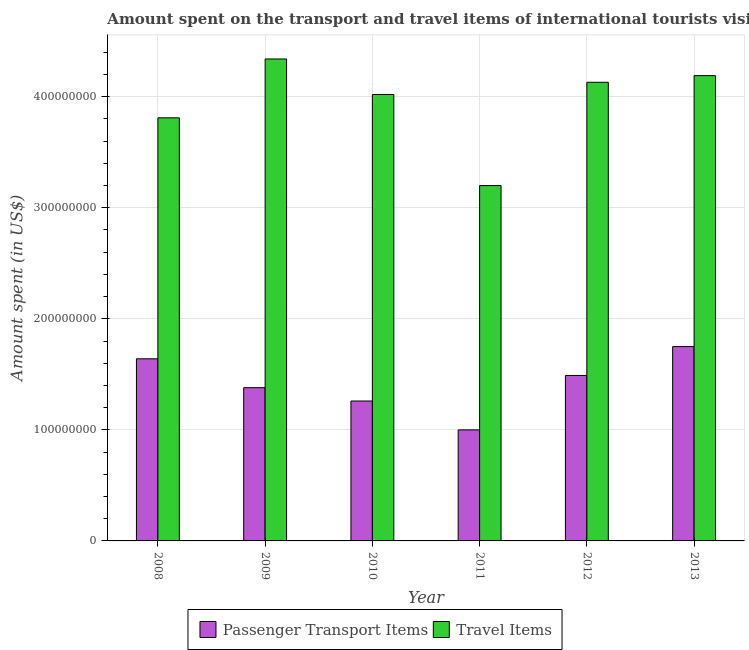How many different coloured bars are there?
Provide a succinct answer. 2. How many groups of bars are there?
Make the answer very short. 6. Are the number of bars per tick equal to the number of legend labels?
Your response must be concise. Yes. How many bars are there on the 1st tick from the left?
Ensure brevity in your answer.  2. How many bars are there on the 1st tick from the right?
Make the answer very short. 2. What is the label of the 2nd group of bars from the left?
Provide a succinct answer. 2009. What is the amount spent in travel items in 2008?
Make the answer very short. 3.81e+08. Across all years, what is the maximum amount spent in travel items?
Provide a succinct answer. 4.34e+08. Across all years, what is the minimum amount spent in travel items?
Make the answer very short. 3.20e+08. In which year was the amount spent on passenger transport items maximum?
Provide a short and direct response. 2013. What is the total amount spent on passenger transport items in the graph?
Ensure brevity in your answer.  8.52e+08. What is the difference between the amount spent in travel items in 2008 and that in 2009?
Offer a very short reply. -5.30e+07. What is the difference between the amount spent in travel items in 2011 and the amount spent on passenger transport items in 2010?
Your answer should be very brief. -8.20e+07. What is the average amount spent in travel items per year?
Offer a very short reply. 3.95e+08. What is the ratio of the amount spent in travel items in 2009 to that in 2011?
Make the answer very short. 1.36. Is the amount spent in travel items in 2009 less than that in 2010?
Provide a short and direct response. No. What is the difference between the highest and the second highest amount spent on passenger transport items?
Offer a terse response. 1.10e+07. What is the difference between the highest and the lowest amount spent in travel items?
Your response must be concise. 1.14e+08. What does the 2nd bar from the left in 2008 represents?
Give a very brief answer. Travel Items. What does the 2nd bar from the right in 2012 represents?
Your response must be concise. Passenger Transport Items. How many bars are there?
Give a very brief answer. 12. How many years are there in the graph?
Your answer should be compact. 6. What is the difference between two consecutive major ticks on the Y-axis?
Ensure brevity in your answer.  1.00e+08. Does the graph contain grids?
Give a very brief answer. Yes. How are the legend labels stacked?
Give a very brief answer. Horizontal. What is the title of the graph?
Your response must be concise. Amount spent on the transport and travel items of international tourists visited in Nepal. Does "Lower secondary education" appear as one of the legend labels in the graph?
Provide a succinct answer. No. What is the label or title of the X-axis?
Offer a very short reply. Year. What is the label or title of the Y-axis?
Keep it short and to the point. Amount spent (in US$). What is the Amount spent (in US$) of Passenger Transport Items in 2008?
Ensure brevity in your answer.  1.64e+08. What is the Amount spent (in US$) of Travel Items in 2008?
Make the answer very short. 3.81e+08. What is the Amount spent (in US$) in Passenger Transport Items in 2009?
Ensure brevity in your answer.  1.38e+08. What is the Amount spent (in US$) of Travel Items in 2009?
Your response must be concise. 4.34e+08. What is the Amount spent (in US$) in Passenger Transport Items in 2010?
Your response must be concise. 1.26e+08. What is the Amount spent (in US$) of Travel Items in 2010?
Give a very brief answer. 4.02e+08. What is the Amount spent (in US$) in Travel Items in 2011?
Your answer should be compact. 3.20e+08. What is the Amount spent (in US$) of Passenger Transport Items in 2012?
Provide a succinct answer. 1.49e+08. What is the Amount spent (in US$) of Travel Items in 2012?
Provide a short and direct response. 4.13e+08. What is the Amount spent (in US$) of Passenger Transport Items in 2013?
Keep it short and to the point. 1.75e+08. What is the Amount spent (in US$) of Travel Items in 2013?
Keep it short and to the point. 4.19e+08. Across all years, what is the maximum Amount spent (in US$) in Passenger Transport Items?
Provide a short and direct response. 1.75e+08. Across all years, what is the maximum Amount spent (in US$) of Travel Items?
Provide a short and direct response. 4.34e+08. Across all years, what is the minimum Amount spent (in US$) in Travel Items?
Keep it short and to the point. 3.20e+08. What is the total Amount spent (in US$) of Passenger Transport Items in the graph?
Provide a short and direct response. 8.52e+08. What is the total Amount spent (in US$) of Travel Items in the graph?
Offer a terse response. 2.37e+09. What is the difference between the Amount spent (in US$) in Passenger Transport Items in 2008 and that in 2009?
Give a very brief answer. 2.60e+07. What is the difference between the Amount spent (in US$) in Travel Items in 2008 and that in 2009?
Make the answer very short. -5.30e+07. What is the difference between the Amount spent (in US$) of Passenger Transport Items in 2008 and that in 2010?
Provide a succinct answer. 3.80e+07. What is the difference between the Amount spent (in US$) in Travel Items in 2008 and that in 2010?
Make the answer very short. -2.10e+07. What is the difference between the Amount spent (in US$) of Passenger Transport Items in 2008 and that in 2011?
Your answer should be compact. 6.40e+07. What is the difference between the Amount spent (in US$) of Travel Items in 2008 and that in 2011?
Your answer should be very brief. 6.10e+07. What is the difference between the Amount spent (in US$) of Passenger Transport Items in 2008 and that in 2012?
Your response must be concise. 1.50e+07. What is the difference between the Amount spent (in US$) of Travel Items in 2008 and that in 2012?
Your response must be concise. -3.20e+07. What is the difference between the Amount spent (in US$) in Passenger Transport Items in 2008 and that in 2013?
Your answer should be compact. -1.10e+07. What is the difference between the Amount spent (in US$) of Travel Items in 2008 and that in 2013?
Offer a terse response. -3.80e+07. What is the difference between the Amount spent (in US$) of Passenger Transport Items in 2009 and that in 2010?
Your response must be concise. 1.20e+07. What is the difference between the Amount spent (in US$) in Travel Items in 2009 and that in 2010?
Give a very brief answer. 3.20e+07. What is the difference between the Amount spent (in US$) in Passenger Transport Items in 2009 and that in 2011?
Offer a very short reply. 3.80e+07. What is the difference between the Amount spent (in US$) of Travel Items in 2009 and that in 2011?
Ensure brevity in your answer.  1.14e+08. What is the difference between the Amount spent (in US$) of Passenger Transport Items in 2009 and that in 2012?
Give a very brief answer. -1.10e+07. What is the difference between the Amount spent (in US$) in Travel Items in 2009 and that in 2012?
Offer a very short reply. 2.10e+07. What is the difference between the Amount spent (in US$) in Passenger Transport Items in 2009 and that in 2013?
Offer a terse response. -3.70e+07. What is the difference between the Amount spent (in US$) in Travel Items in 2009 and that in 2013?
Your answer should be compact. 1.50e+07. What is the difference between the Amount spent (in US$) in Passenger Transport Items in 2010 and that in 2011?
Offer a very short reply. 2.60e+07. What is the difference between the Amount spent (in US$) in Travel Items in 2010 and that in 2011?
Your response must be concise. 8.20e+07. What is the difference between the Amount spent (in US$) of Passenger Transport Items in 2010 and that in 2012?
Your answer should be compact. -2.30e+07. What is the difference between the Amount spent (in US$) of Travel Items in 2010 and that in 2012?
Provide a succinct answer. -1.10e+07. What is the difference between the Amount spent (in US$) of Passenger Transport Items in 2010 and that in 2013?
Offer a terse response. -4.90e+07. What is the difference between the Amount spent (in US$) of Travel Items in 2010 and that in 2013?
Your response must be concise. -1.70e+07. What is the difference between the Amount spent (in US$) in Passenger Transport Items in 2011 and that in 2012?
Make the answer very short. -4.90e+07. What is the difference between the Amount spent (in US$) in Travel Items in 2011 and that in 2012?
Keep it short and to the point. -9.30e+07. What is the difference between the Amount spent (in US$) of Passenger Transport Items in 2011 and that in 2013?
Offer a very short reply. -7.50e+07. What is the difference between the Amount spent (in US$) in Travel Items in 2011 and that in 2013?
Your answer should be compact. -9.90e+07. What is the difference between the Amount spent (in US$) of Passenger Transport Items in 2012 and that in 2013?
Your answer should be compact. -2.60e+07. What is the difference between the Amount spent (in US$) in Travel Items in 2012 and that in 2013?
Your answer should be very brief. -6.00e+06. What is the difference between the Amount spent (in US$) in Passenger Transport Items in 2008 and the Amount spent (in US$) in Travel Items in 2009?
Your response must be concise. -2.70e+08. What is the difference between the Amount spent (in US$) of Passenger Transport Items in 2008 and the Amount spent (in US$) of Travel Items in 2010?
Ensure brevity in your answer.  -2.38e+08. What is the difference between the Amount spent (in US$) of Passenger Transport Items in 2008 and the Amount spent (in US$) of Travel Items in 2011?
Make the answer very short. -1.56e+08. What is the difference between the Amount spent (in US$) in Passenger Transport Items in 2008 and the Amount spent (in US$) in Travel Items in 2012?
Offer a very short reply. -2.49e+08. What is the difference between the Amount spent (in US$) of Passenger Transport Items in 2008 and the Amount spent (in US$) of Travel Items in 2013?
Provide a succinct answer. -2.55e+08. What is the difference between the Amount spent (in US$) of Passenger Transport Items in 2009 and the Amount spent (in US$) of Travel Items in 2010?
Ensure brevity in your answer.  -2.64e+08. What is the difference between the Amount spent (in US$) in Passenger Transport Items in 2009 and the Amount spent (in US$) in Travel Items in 2011?
Your answer should be compact. -1.82e+08. What is the difference between the Amount spent (in US$) in Passenger Transport Items in 2009 and the Amount spent (in US$) in Travel Items in 2012?
Keep it short and to the point. -2.75e+08. What is the difference between the Amount spent (in US$) of Passenger Transport Items in 2009 and the Amount spent (in US$) of Travel Items in 2013?
Keep it short and to the point. -2.81e+08. What is the difference between the Amount spent (in US$) of Passenger Transport Items in 2010 and the Amount spent (in US$) of Travel Items in 2011?
Your answer should be compact. -1.94e+08. What is the difference between the Amount spent (in US$) of Passenger Transport Items in 2010 and the Amount spent (in US$) of Travel Items in 2012?
Provide a succinct answer. -2.87e+08. What is the difference between the Amount spent (in US$) of Passenger Transport Items in 2010 and the Amount spent (in US$) of Travel Items in 2013?
Provide a short and direct response. -2.93e+08. What is the difference between the Amount spent (in US$) of Passenger Transport Items in 2011 and the Amount spent (in US$) of Travel Items in 2012?
Offer a very short reply. -3.13e+08. What is the difference between the Amount spent (in US$) of Passenger Transport Items in 2011 and the Amount spent (in US$) of Travel Items in 2013?
Your answer should be very brief. -3.19e+08. What is the difference between the Amount spent (in US$) of Passenger Transport Items in 2012 and the Amount spent (in US$) of Travel Items in 2013?
Your answer should be compact. -2.70e+08. What is the average Amount spent (in US$) of Passenger Transport Items per year?
Your answer should be compact. 1.42e+08. What is the average Amount spent (in US$) in Travel Items per year?
Your response must be concise. 3.95e+08. In the year 2008, what is the difference between the Amount spent (in US$) in Passenger Transport Items and Amount spent (in US$) in Travel Items?
Your answer should be very brief. -2.17e+08. In the year 2009, what is the difference between the Amount spent (in US$) of Passenger Transport Items and Amount spent (in US$) of Travel Items?
Offer a terse response. -2.96e+08. In the year 2010, what is the difference between the Amount spent (in US$) in Passenger Transport Items and Amount spent (in US$) in Travel Items?
Provide a succinct answer. -2.76e+08. In the year 2011, what is the difference between the Amount spent (in US$) in Passenger Transport Items and Amount spent (in US$) in Travel Items?
Your answer should be very brief. -2.20e+08. In the year 2012, what is the difference between the Amount spent (in US$) in Passenger Transport Items and Amount spent (in US$) in Travel Items?
Give a very brief answer. -2.64e+08. In the year 2013, what is the difference between the Amount spent (in US$) of Passenger Transport Items and Amount spent (in US$) of Travel Items?
Make the answer very short. -2.44e+08. What is the ratio of the Amount spent (in US$) of Passenger Transport Items in 2008 to that in 2009?
Offer a very short reply. 1.19. What is the ratio of the Amount spent (in US$) in Travel Items in 2008 to that in 2009?
Give a very brief answer. 0.88. What is the ratio of the Amount spent (in US$) in Passenger Transport Items in 2008 to that in 2010?
Offer a very short reply. 1.3. What is the ratio of the Amount spent (in US$) of Travel Items in 2008 to that in 2010?
Provide a succinct answer. 0.95. What is the ratio of the Amount spent (in US$) in Passenger Transport Items in 2008 to that in 2011?
Your answer should be compact. 1.64. What is the ratio of the Amount spent (in US$) of Travel Items in 2008 to that in 2011?
Provide a short and direct response. 1.19. What is the ratio of the Amount spent (in US$) in Passenger Transport Items in 2008 to that in 2012?
Ensure brevity in your answer.  1.1. What is the ratio of the Amount spent (in US$) in Travel Items in 2008 to that in 2012?
Offer a very short reply. 0.92. What is the ratio of the Amount spent (in US$) of Passenger Transport Items in 2008 to that in 2013?
Provide a short and direct response. 0.94. What is the ratio of the Amount spent (in US$) in Travel Items in 2008 to that in 2013?
Offer a very short reply. 0.91. What is the ratio of the Amount spent (in US$) in Passenger Transport Items in 2009 to that in 2010?
Provide a short and direct response. 1.1. What is the ratio of the Amount spent (in US$) of Travel Items in 2009 to that in 2010?
Keep it short and to the point. 1.08. What is the ratio of the Amount spent (in US$) of Passenger Transport Items in 2009 to that in 2011?
Your answer should be very brief. 1.38. What is the ratio of the Amount spent (in US$) of Travel Items in 2009 to that in 2011?
Provide a succinct answer. 1.36. What is the ratio of the Amount spent (in US$) of Passenger Transport Items in 2009 to that in 2012?
Make the answer very short. 0.93. What is the ratio of the Amount spent (in US$) of Travel Items in 2009 to that in 2012?
Make the answer very short. 1.05. What is the ratio of the Amount spent (in US$) of Passenger Transport Items in 2009 to that in 2013?
Provide a short and direct response. 0.79. What is the ratio of the Amount spent (in US$) in Travel Items in 2009 to that in 2013?
Offer a terse response. 1.04. What is the ratio of the Amount spent (in US$) in Passenger Transport Items in 2010 to that in 2011?
Your response must be concise. 1.26. What is the ratio of the Amount spent (in US$) of Travel Items in 2010 to that in 2011?
Offer a very short reply. 1.26. What is the ratio of the Amount spent (in US$) of Passenger Transport Items in 2010 to that in 2012?
Give a very brief answer. 0.85. What is the ratio of the Amount spent (in US$) in Travel Items in 2010 to that in 2012?
Give a very brief answer. 0.97. What is the ratio of the Amount spent (in US$) in Passenger Transport Items in 2010 to that in 2013?
Ensure brevity in your answer.  0.72. What is the ratio of the Amount spent (in US$) of Travel Items in 2010 to that in 2013?
Provide a succinct answer. 0.96. What is the ratio of the Amount spent (in US$) in Passenger Transport Items in 2011 to that in 2012?
Give a very brief answer. 0.67. What is the ratio of the Amount spent (in US$) in Travel Items in 2011 to that in 2012?
Provide a short and direct response. 0.77. What is the ratio of the Amount spent (in US$) of Passenger Transport Items in 2011 to that in 2013?
Offer a terse response. 0.57. What is the ratio of the Amount spent (in US$) of Travel Items in 2011 to that in 2013?
Ensure brevity in your answer.  0.76. What is the ratio of the Amount spent (in US$) in Passenger Transport Items in 2012 to that in 2013?
Offer a terse response. 0.85. What is the ratio of the Amount spent (in US$) in Travel Items in 2012 to that in 2013?
Offer a terse response. 0.99. What is the difference between the highest and the second highest Amount spent (in US$) in Passenger Transport Items?
Provide a succinct answer. 1.10e+07. What is the difference between the highest and the second highest Amount spent (in US$) in Travel Items?
Your answer should be very brief. 1.50e+07. What is the difference between the highest and the lowest Amount spent (in US$) in Passenger Transport Items?
Keep it short and to the point. 7.50e+07. What is the difference between the highest and the lowest Amount spent (in US$) in Travel Items?
Make the answer very short. 1.14e+08. 